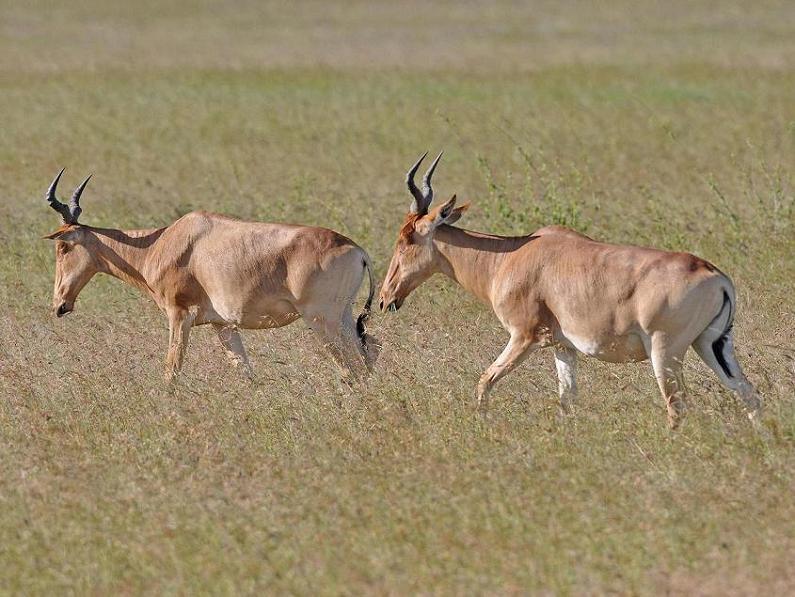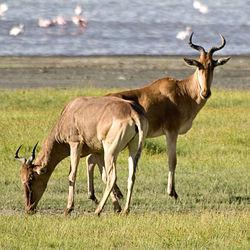The first image is the image on the left, the second image is the image on the right. Considering the images on both sides, is "The two images contain a total of three animals." valid? Answer yes or no. No. The first image is the image on the left, the second image is the image on the right. Considering the images on both sides, is "An image shows just one horned animal, standing with its head in profile." valid? Answer yes or no. No. 